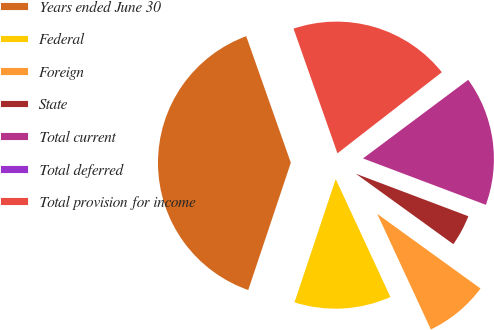<chart> <loc_0><loc_0><loc_500><loc_500><pie_chart><fcel>Years ended June 30<fcel>Federal<fcel>Foreign<fcel>State<fcel>Total current<fcel>Total deferred<fcel>Total provision for income<nl><fcel>39.47%<fcel>12.05%<fcel>8.13%<fcel>4.21%<fcel>15.96%<fcel>0.3%<fcel>19.88%<nl></chart> 